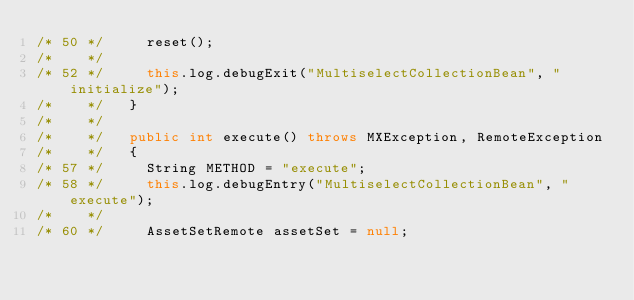<code> <loc_0><loc_0><loc_500><loc_500><_Java_>/* 50 */     reset();
/*    */ 
/* 52 */     this.log.debugExit("MultiselectCollectionBean", "initialize");
/*    */   }
/*    */ 
/*    */   public int execute() throws MXException, RemoteException
/*    */   {
/* 57 */     String METHOD = "execute";
/* 58 */     this.log.debugEntry("MultiselectCollectionBean", "execute");
/*    */ 
/* 60 */     AssetSetRemote assetSet = null;</code> 